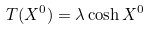Convert formula to latex. <formula><loc_0><loc_0><loc_500><loc_500>T ( X ^ { 0 } ) = \lambda \cosh X ^ { 0 }</formula> 